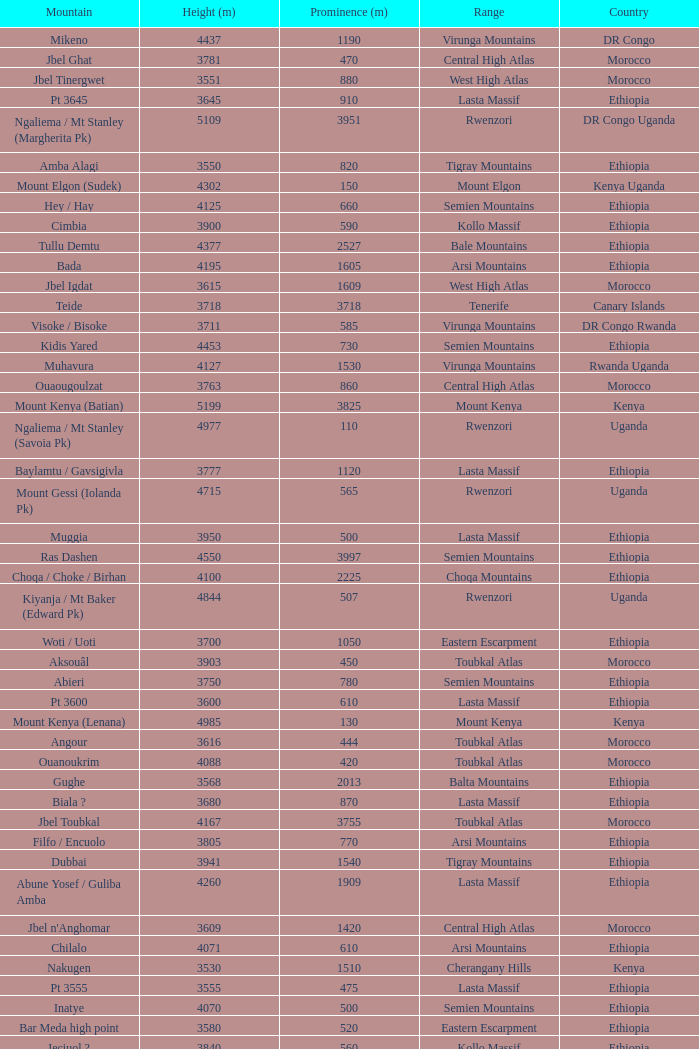Which Country has a Prominence (m) smaller than 1540, and a Height (m) smaller than 3530, and a Range of virunga mountains, and a Mountain of nyiragongo? DR Congo. 